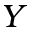<formula> <loc_0><loc_0><loc_500><loc_500>Y</formula> 